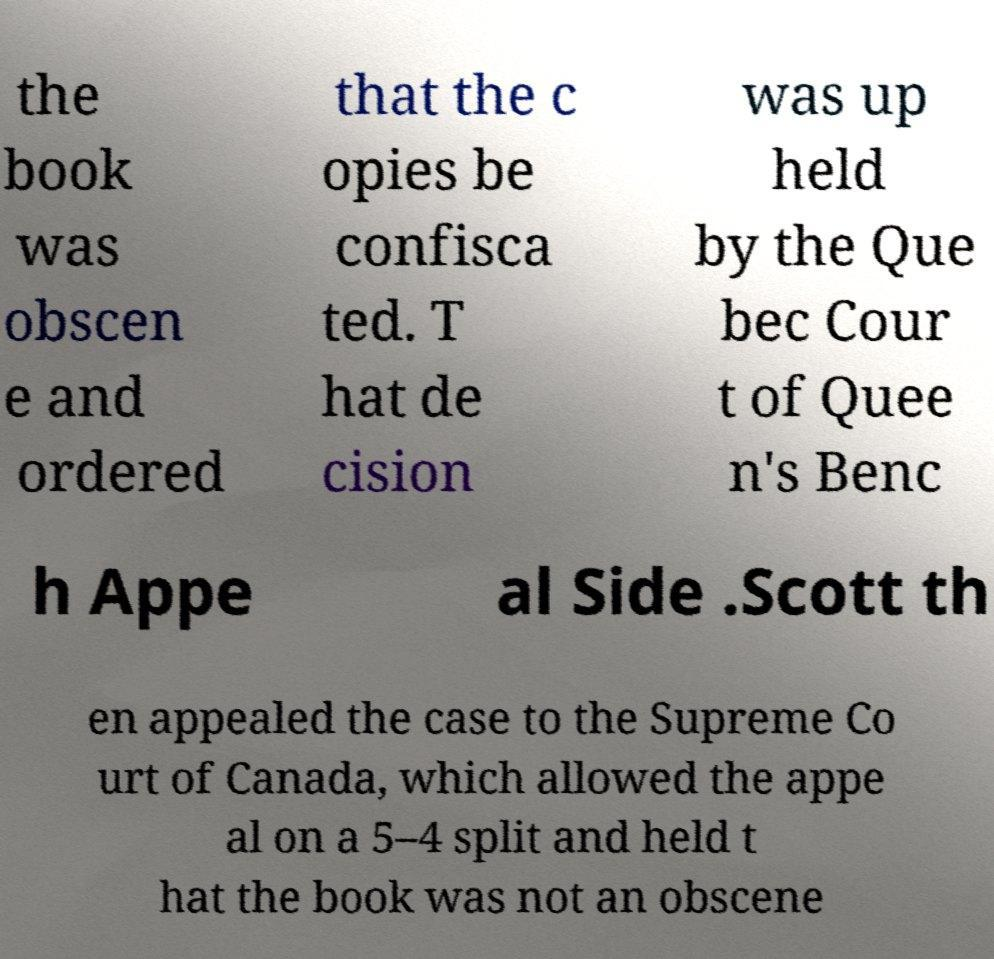Could you assist in decoding the text presented in this image and type it out clearly? the book was obscen e and ordered that the c opies be confisca ted. T hat de cision was up held by the Que bec Cour t of Quee n's Benc h Appe al Side .Scott th en appealed the case to the Supreme Co urt of Canada, which allowed the appe al on a 5–4 split and held t hat the book was not an obscene 